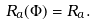Convert formula to latex. <formula><loc_0><loc_0><loc_500><loc_500>R _ { a } ( \Phi ) & = R _ { a } .</formula> 